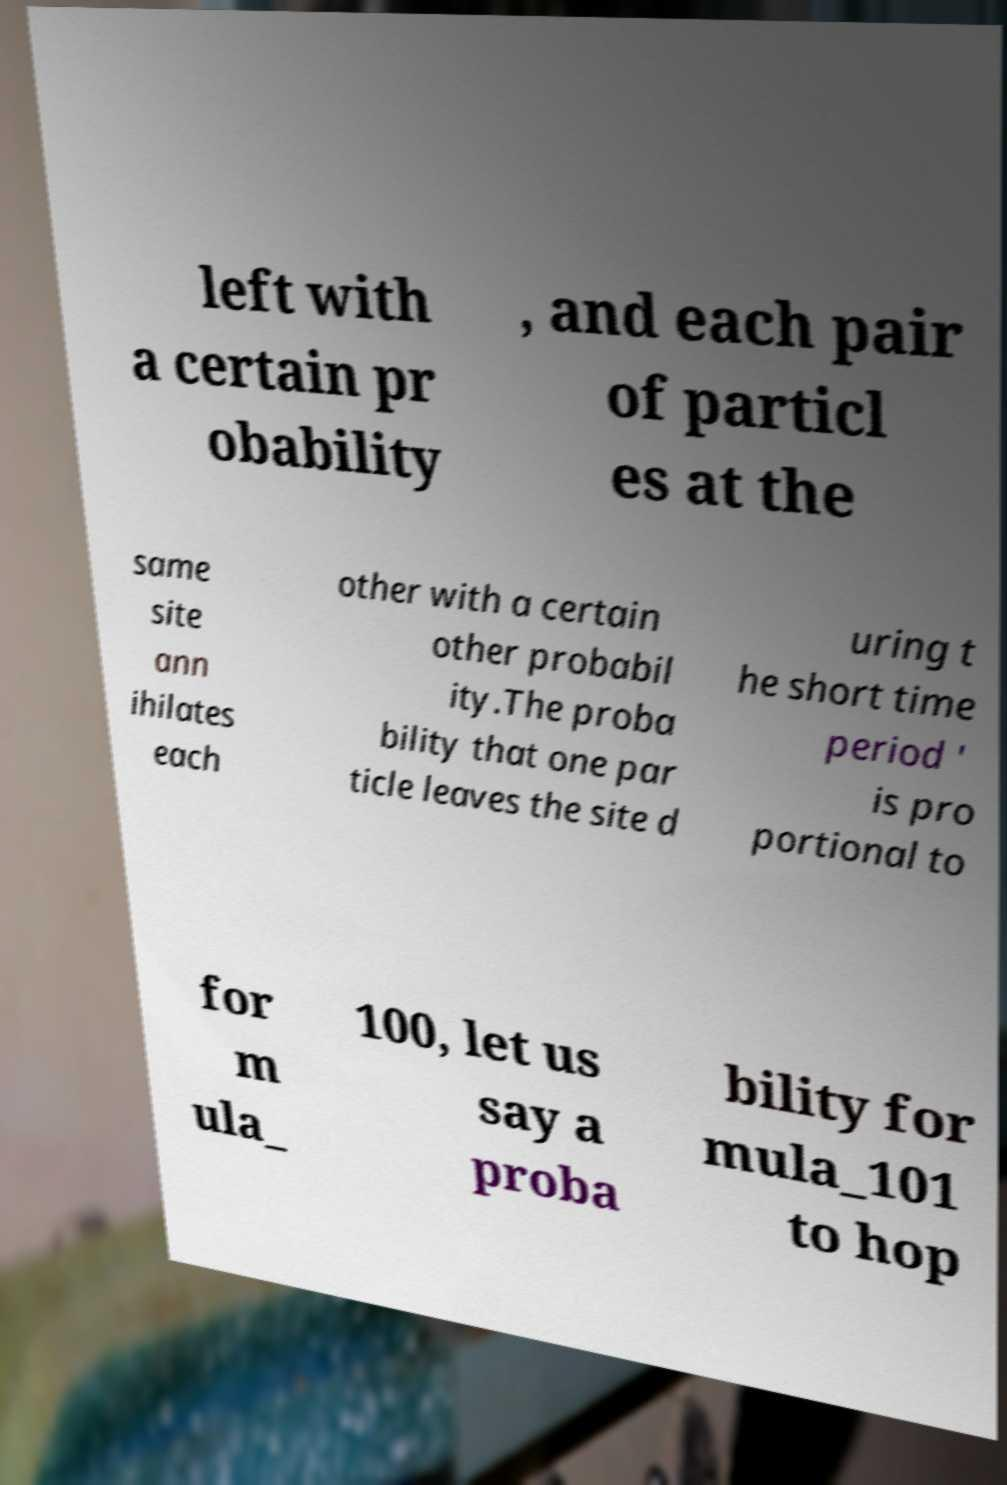There's text embedded in this image that I need extracted. Can you transcribe it verbatim? left with a certain pr obability , and each pair of particl es at the same site ann ihilates each other with a certain other probabil ity.The proba bility that one par ticle leaves the site d uring t he short time period ' is pro portional to for m ula_ 100, let us say a proba bility for mula_101 to hop 